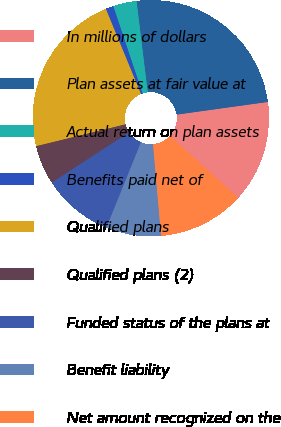Convert chart. <chart><loc_0><loc_0><loc_500><loc_500><pie_chart><fcel>In millions of dollars<fcel>Plan assets at fair value at<fcel>Actual return on plan assets<fcel>Benefits paid net of<fcel>Qualified plans<fcel>Qualified plans (2)<fcel>Funded status of the plans at<fcel>Benefit liability<fcel>Net amount recognized on the<nl><fcel>13.98%<fcel>24.74%<fcel>3.22%<fcel>1.07%<fcel>22.59%<fcel>5.37%<fcel>9.68%<fcel>7.52%<fcel>11.83%<nl></chart> 